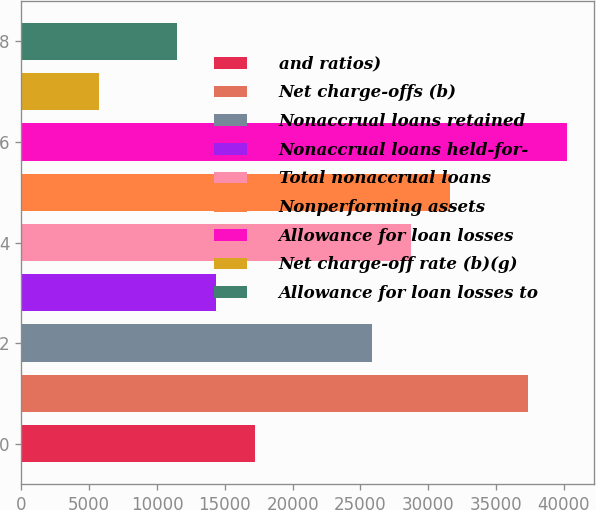Convert chart to OTSL. <chart><loc_0><loc_0><loc_500><loc_500><bar_chart><fcel>and ratios)<fcel>Net charge-offs (b)<fcel>Nonaccrual loans retained<fcel>Nonaccrual loans held-for-<fcel>Total nonaccrual loans<fcel>Nonperforming assets<fcel>Allowance for loan losses<fcel>Net charge-off rate (b)(g)<fcel>Allowance for loan losses to<nl><fcel>17225.9<fcel>37319.6<fcel>25837.5<fcel>14355.3<fcel>28708<fcel>31578.5<fcel>40190.1<fcel>5743.75<fcel>11484.8<nl></chart> 